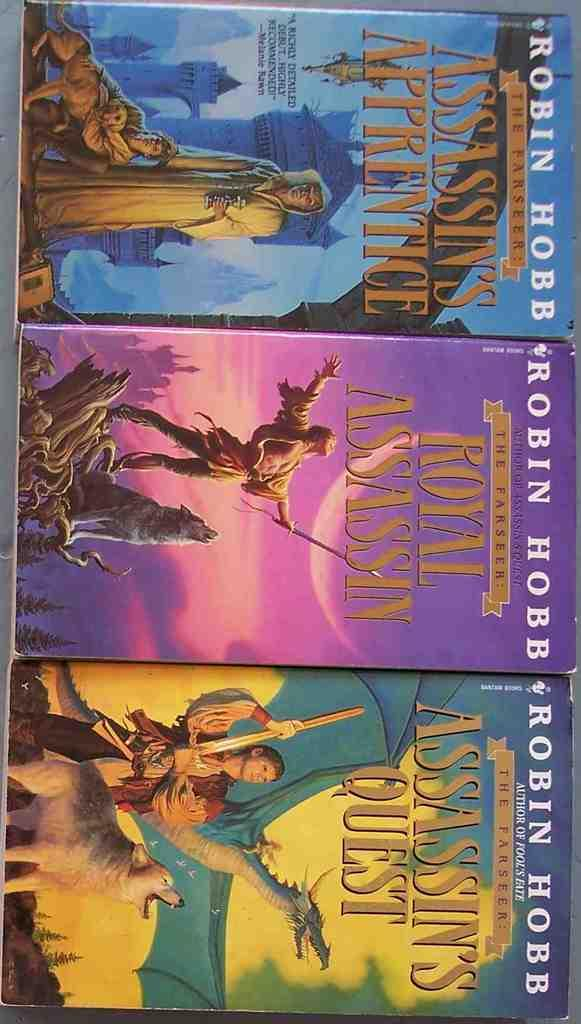Provide a one-sentence caption for the provided image. Three Robin Hobb novels are lined up, each with a different color cover. 